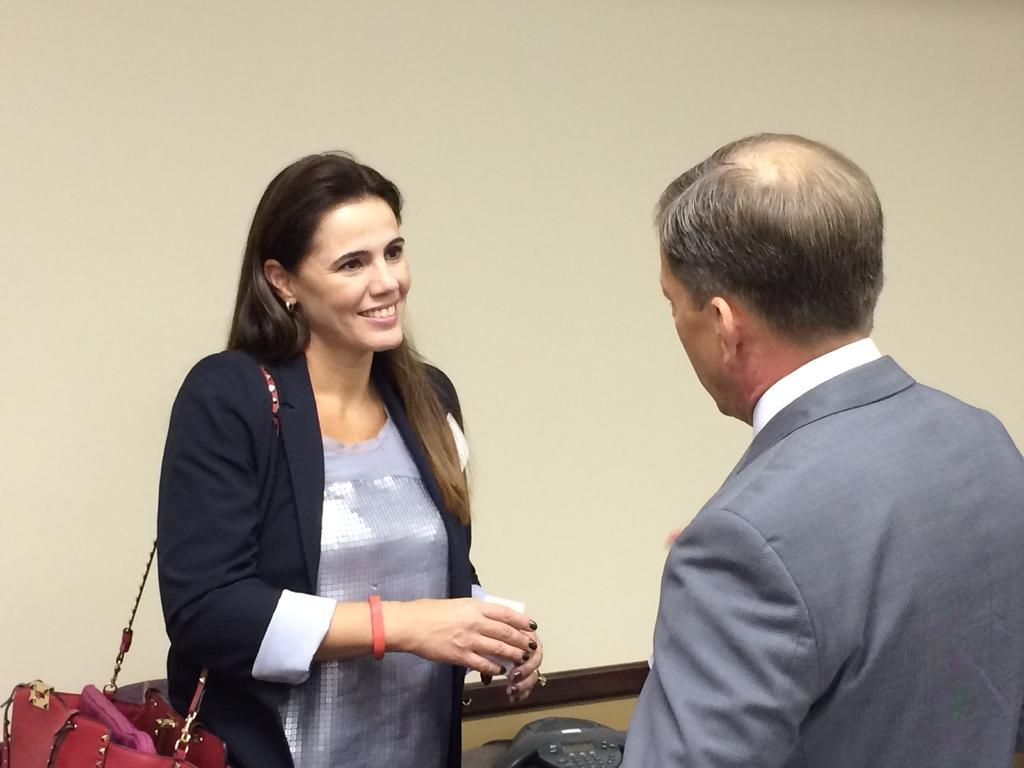How many people are in the image? There are two people in the image. Can you describe the positions of the people in the image? A man is on the right side of the image, and a woman is on the left side of the image. What is the woman doing in the image? The woman is looking at the man and smiling. What is the woman wearing that is red in color? The woman is wearing a red color bag. What can be seen in the background of the image? There is a wall in the background of the image. What type of beetle can be seen crawling on the man's shoulder in the image? There is no beetle present on the man's shoulder in the image. What test is the woman taking in the image? There is no test being taken in the image; the woman is simply looking at the man and smiling. 